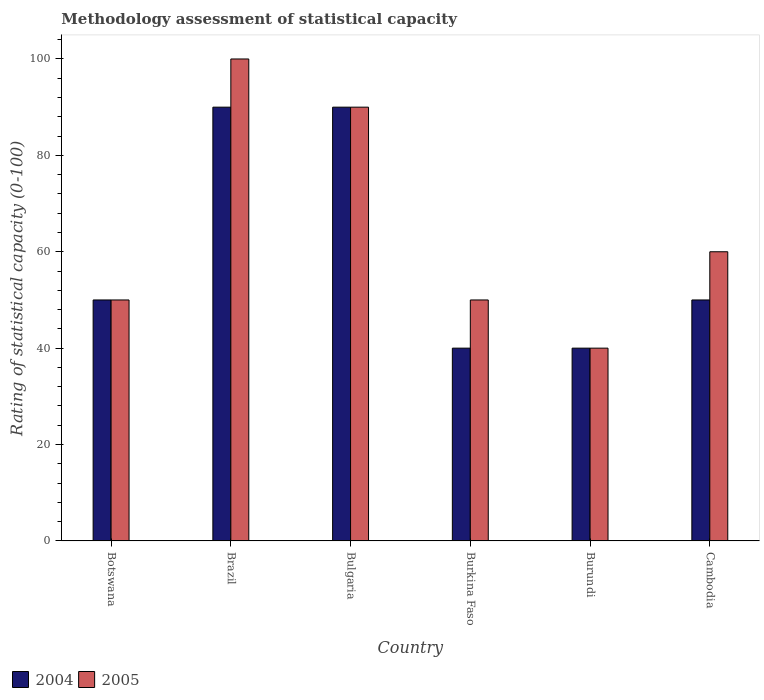Are the number of bars per tick equal to the number of legend labels?
Your answer should be compact. Yes. How many bars are there on the 3rd tick from the left?
Offer a very short reply. 2. What is the label of the 5th group of bars from the left?
Give a very brief answer. Burundi. What is the rating of statistical capacity in 2005 in Cambodia?
Your answer should be compact. 60. Across all countries, what is the maximum rating of statistical capacity in 2004?
Make the answer very short. 90. In which country was the rating of statistical capacity in 2004 minimum?
Offer a terse response. Burkina Faso. What is the total rating of statistical capacity in 2004 in the graph?
Your answer should be compact. 360. What is the difference between the rating of statistical capacity in 2005 in Botswana and that in Cambodia?
Give a very brief answer. -10. What is the average rating of statistical capacity in 2005 per country?
Your answer should be very brief. 65. In how many countries, is the rating of statistical capacity in 2004 greater than 28?
Your answer should be compact. 6. What is the ratio of the rating of statistical capacity in 2004 in Brazil to that in Bulgaria?
Provide a succinct answer. 1. Is the rating of statistical capacity in 2005 in Brazil less than that in Burkina Faso?
Ensure brevity in your answer.  No. In how many countries, is the rating of statistical capacity in 2004 greater than the average rating of statistical capacity in 2004 taken over all countries?
Your answer should be compact. 2. What does the 2nd bar from the right in Burkina Faso represents?
Your response must be concise. 2004. How many countries are there in the graph?
Provide a succinct answer. 6. Does the graph contain grids?
Make the answer very short. No. Where does the legend appear in the graph?
Your answer should be compact. Bottom left. How many legend labels are there?
Ensure brevity in your answer.  2. How are the legend labels stacked?
Offer a very short reply. Horizontal. What is the title of the graph?
Make the answer very short. Methodology assessment of statistical capacity. What is the label or title of the Y-axis?
Keep it short and to the point. Rating of statistical capacity (0-100). What is the Rating of statistical capacity (0-100) of 2004 in Botswana?
Offer a terse response. 50. What is the Rating of statistical capacity (0-100) in 2005 in Botswana?
Your response must be concise. 50. What is the Rating of statistical capacity (0-100) in 2004 in Bulgaria?
Offer a very short reply. 90. What is the Rating of statistical capacity (0-100) of 2005 in Bulgaria?
Give a very brief answer. 90. What is the Rating of statistical capacity (0-100) in 2005 in Cambodia?
Ensure brevity in your answer.  60. Across all countries, what is the maximum Rating of statistical capacity (0-100) of 2005?
Make the answer very short. 100. Across all countries, what is the minimum Rating of statistical capacity (0-100) of 2005?
Make the answer very short. 40. What is the total Rating of statistical capacity (0-100) in 2004 in the graph?
Your response must be concise. 360. What is the total Rating of statistical capacity (0-100) in 2005 in the graph?
Your answer should be compact. 390. What is the difference between the Rating of statistical capacity (0-100) in 2005 in Botswana and that in Bulgaria?
Provide a succinct answer. -40. What is the difference between the Rating of statistical capacity (0-100) of 2004 in Botswana and that in Burkina Faso?
Your answer should be very brief. 10. What is the difference between the Rating of statistical capacity (0-100) in 2005 in Botswana and that in Burkina Faso?
Offer a terse response. 0. What is the difference between the Rating of statistical capacity (0-100) of 2004 in Botswana and that in Burundi?
Ensure brevity in your answer.  10. What is the difference between the Rating of statistical capacity (0-100) in 2005 in Botswana and that in Burundi?
Offer a very short reply. 10. What is the difference between the Rating of statistical capacity (0-100) in 2004 in Brazil and that in Bulgaria?
Your answer should be very brief. 0. What is the difference between the Rating of statistical capacity (0-100) in 2005 in Brazil and that in Burkina Faso?
Keep it short and to the point. 50. What is the difference between the Rating of statistical capacity (0-100) in 2005 in Brazil and that in Burundi?
Your response must be concise. 60. What is the difference between the Rating of statistical capacity (0-100) of 2005 in Brazil and that in Cambodia?
Offer a very short reply. 40. What is the difference between the Rating of statistical capacity (0-100) of 2004 in Bulgaria and that in Burkina Faso?
Offer a terse response. 50. What is the difference between the Rating of statistical capacity (0-100) in 2004 in Bulgaria and that in Burundi?
Give a very brief answer. 50. What is the difference between the Rating of statistical capacity (0-100) in 2005 in Bulgaria and that in Burundi?
Offer a very short reply. 50. What is the difference between the Rating of statistical capacity (0-100) of 2004 in Burkina Faso and that in Burundi?
Provide a succinct answer. 0. What is the difference between the Rating of statistical capacity (0-100) in 2005 in Burkina Faso and that in Cambodia?
Your response must be concise. -10. What is the difference between the Rating of statistical capacity (0-100) of 2005 in Burundi and that in Cambodia?
Give a very brief answer. -20. What is the difference between the Rating of statistical capacity (0-100) in 2004 in Botswana and the Rating of statistical capacity (0-100) in 2005 in Brazil?
Offer a terse response. -50. What is the difference between the Rating of statistical capacity (0-100) of 2004 in Botswana and the Rating of statistical capacity (0-100) of 2005 in Burkina Faso?
Your answer should be compact. 0. What is the difference between the Rating of statistical capacity (0-100) in 2004 in Botswana and the Rating of statistical capacity (0-100) in 2005 in Cambodia?
Your answer should be compact. -10. What is the difference between the Rating of statistical capacity (0-100) of 2004 in Brazil and the Rating of statistical capacity (0-100) of 2005 in Bulgaria?
Offer a terse response. 0. What is the difference between the Rating of statistical capacity (0-100) in 2004 in Brazil and the Rating of statistical capacity (0-100) in 2005 in Burundi?
Offer a very short reply. 50. What is the difference between the Rating of statistical capacity (0-100) in 2004 in Bulgaria and the Rating of statistical capacity (0-100) in 2005 in Burkina Faso?
Ensure brevity in your answer.  40. What is the difference between the Rating of statistical capacity (0-100) of 2004 in Bulgaria and the Rating of statistical capacity (0-100) of 2005 in Burundi?
Your response must be concise. 50. What is the difference between the Rating of statistical capacity (0-100) of 2004 in Bulgaria and the Rating of statistical capacity (0-100) of 2005 in Cambodia?
Give a very brief answer. 30. What is the difference between the Rating of statistical capacity (0-100) of 2004 in Burkina Faso and the Rating of statistical capacity (0-100) of 2005 in Cambodia?
Offer a very short reply. -20. What is the difference between the Rating of statistical capacity (0-100) in 2004 in Burundi and the Rating of statistical capacity (0-100) in 2005 in Cambodia?
Offer a terse response. -20. What is the average Rating of statistical capacity (0-100) of 2004 per country?
Provide a succinct answer. 60. What is the difference between the Rating of statistical capacity (0-100) of 2004 and Rating of statistical capacity (0-100) of 2005 in Bulgaria?
Your answer should be compact. 0. What is the difference between the Rating of statistical capacity (0-100) of 2004 and Rating of statistical capacity (0-100) of 2005 in Burkina Faso?
Your answer should be compact. -10. What is the difference between the Rating of statistical capacity (0-100) in 2004 and Rating of statistical capacity (0-100) in 2005 in Cambodia?
Your response must be concise. -10. What is the ratio of the Rating of statistical capacity (0-100) of 2004 in Botswana to that in Brazil?
Ensure brevity in your answer.  0.56. What is the ratio of the Rating of statistical capacity (0-100) of 2004 in Botswana to that in Bulgaria?
Provide a short and direct response. 0.56. What is the ratio of the Rating of statistical capacity (0-100) in 2005 in Botswana to that in Bulgaria?
Your answer should be very brief. 0.56. What is the ratio of the Rating of statistical capacity (0-100) of 2004 in Botswana to that in Burkina Faso?
Offer a terse response. 1.25. What is the ratio of the Rating of statistical capacity (0-100) of 2004 in Botswana to that in Burundi?
Make the answer very short. 1.25. What is the ratio of the Rating of statistical capacity (0-100) in 2004 in Botswana to that in Cambodia?
Your answer should be very brief. 1. What is the ratio of the Rating of statistical capacity (0-100) in 2004 in Brazil to that in Bulgaria?
Keep it short and to the point. 1. What is the ratio of the Rating of statistical capacity (0-100) of 2004 in Brazil to that in Burkina Faso?
Make the answer very short. 2.25. What is the ratio of the Rating of statistical capacity (0-100) of 2005 in Brazil to that in Burkina Faso?
Offer a terse response. 2. What is the ratio of the Rating of statistical capacity (0-100) of 2004 in Brazil to that in Burundi?
Keep it short and to the point. 2.25. What is the ratio of the Rating of statistical capacity (0-100) in 2005 in Brazil to that in Burundi?
Your response must be concise. 2.5. What is the ratio of the Rating of statistical capacity (0-100) of 2004 in Bulgaria to that in Burkina Faso?
Give a very brief answer. 2.25. What is the ratio of the Rating of statistical capacity (0-100) of 2005 in Bulgaria to that in Burkina Faso?
Ensure brevity in your answer.  1.8. What is the ratio of the Rating of statistical capacity (0-100) of 2004 in Bulgaria to that in Burundi?
Your answer should be very brief. 2.25. What is the ratio of the Rating of statistical capacity (0-100) in 2005 in Bulgaria to that in Burundi?
Your answer should be compact. 2.25. What is the ratio of the Rating of statistical capacity (0-100) in 2005 in Bulgaria to that in Cambodia?
Keep it short and to the point. 1.5. What is the ratio of the Rating of statistical capacity (0-100) of 2004 in Burkina Faso to that in Cambodia?
Ensure brevity in your answer.  0.8. What is the ratio of the Rating of statistical capacity (0-100) in 2005 in Burkina Faso to that in Cambodia?
Ensure brevity in your answer.  0.83. What is the ratio of the Rating of statistical capacity (0-100) of 2005 in Burundi to that in Cambodia?
Provide a short and direct response. 0.67. What is the difference between the highest and the second highest Rating of statistical capacity (0-100) of 2004?
Your answer should be compact. 0. What is the difference between the highest and the lowest Rating of statistical capacity (0-100) of 2004?
Provide a succinct answer. 50. What is the difference between the highest and the lowest Rating of statistical capacity (0-100) of 2005?
Offer a very short reply. 60. 